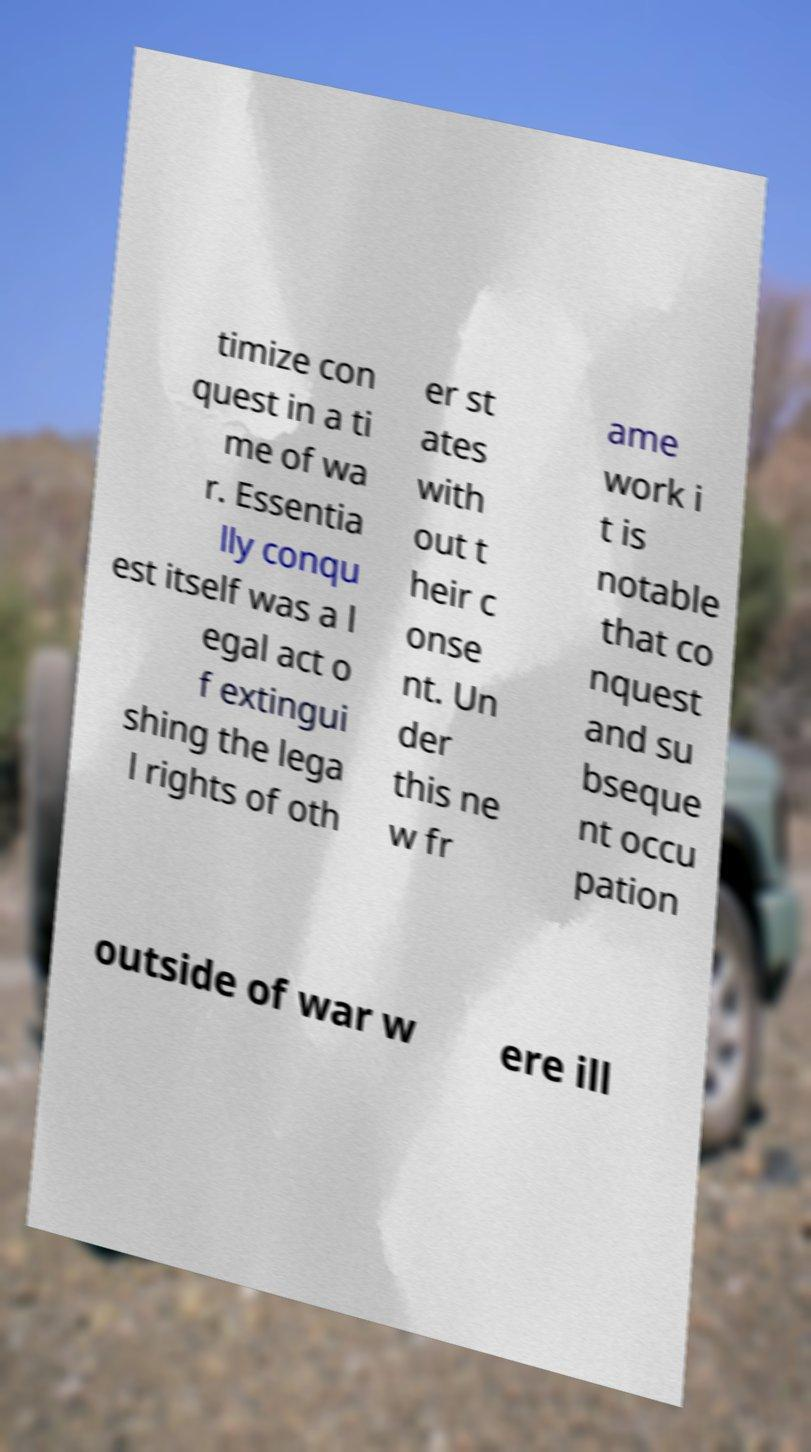For documentation purposes, I need the text within this image transcribed. Could you provide that? timize con quest in a ti me of wa r. Essentia lly conqu est itself was a l egal act o f extingui shing the lega l rights of oth er st ates with out t heir c onse nt. Un der this ne w fr ame work i t is notable that co nquest and su bseque nt occu pation outside of war w ere ill 